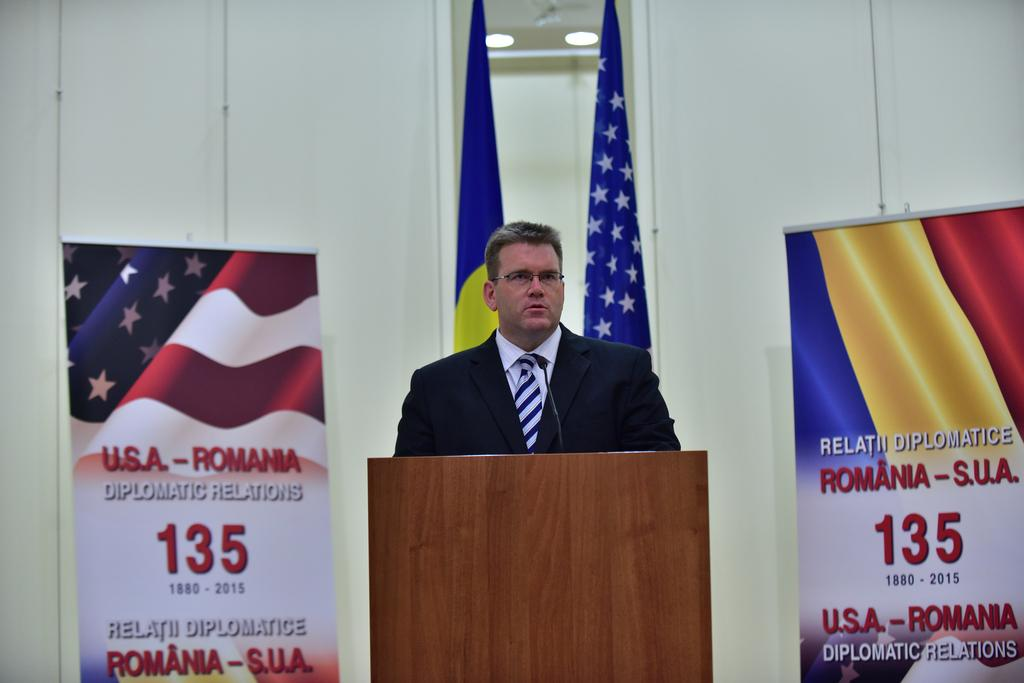What is located in the foreground of the image? There is a table in the foreground of the image. Who is positioned near the table? There is a man behind the table. What can be seen in the background of the image? There are two banners and two flags in the background of the image, as well as a wall. How many ants can be seen crawling on the table in the image? There are no ants visible on the table in the image. What type of nation is represented by the flags in the image? The image does not provide enough information to determine the nation represented by the flags. 